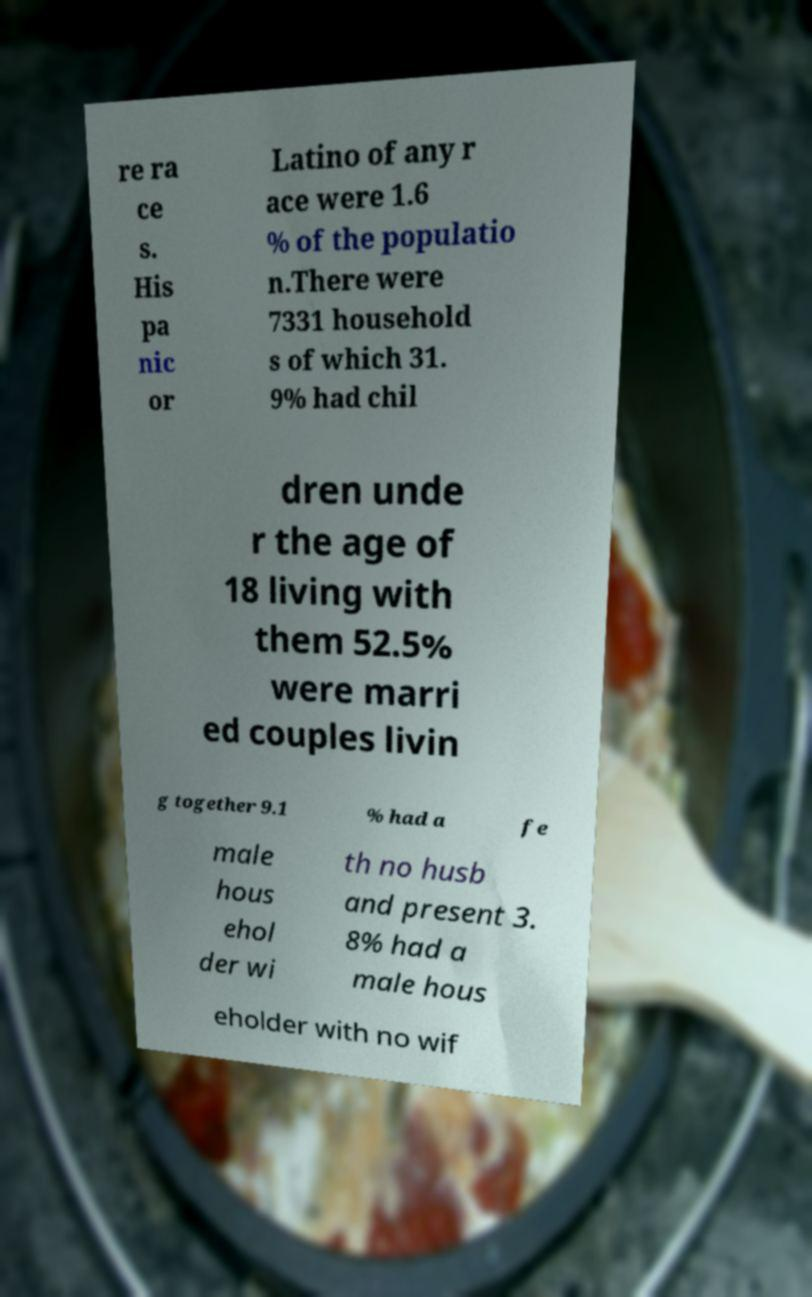For documentation purposes, I need the text within this image transcribed. Could you provide that? re ra ce s. His pa nic or Latino of any r ace were 1.6 % of the populatio n.There were 7331 household s of which 31. 9% had chil dren unde r the age of 18 living with them 52.5% were marri ed couples livin g together 9.1 % had a fe male hous ehol der wi th no husb and present 3. 8% had a male hous eholder with no wif 